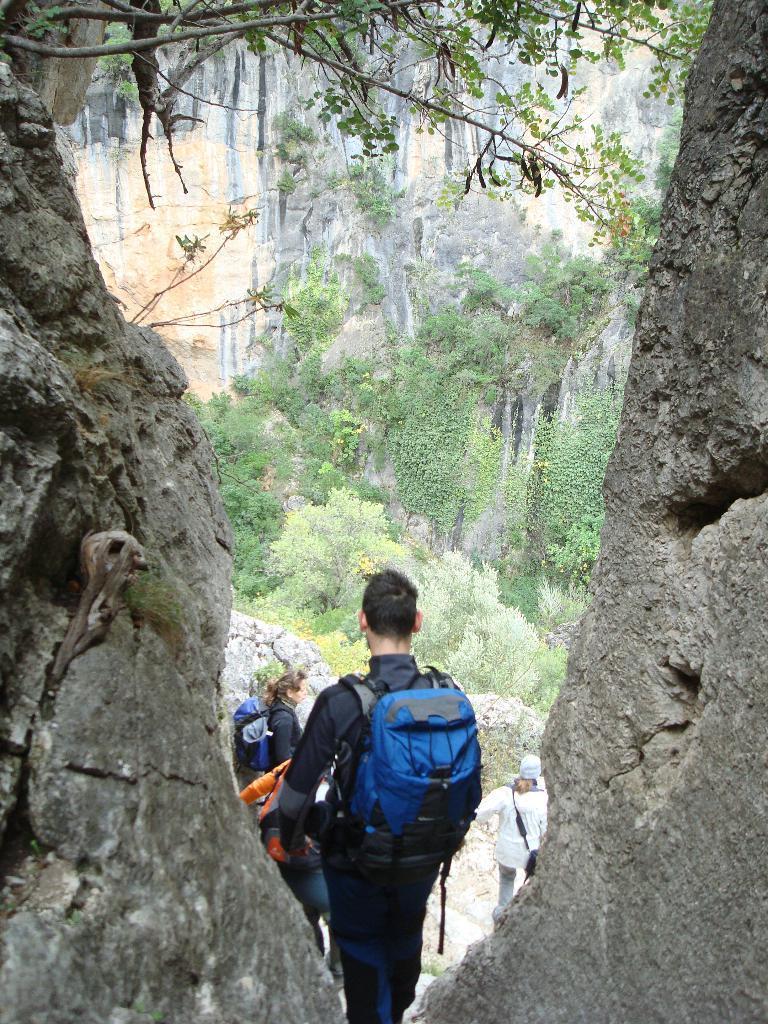Could you give a brief overview of what you see in this image? This picture shows few people standing and we see they wore bags and we see a human wore cap on the head and we see trees. 